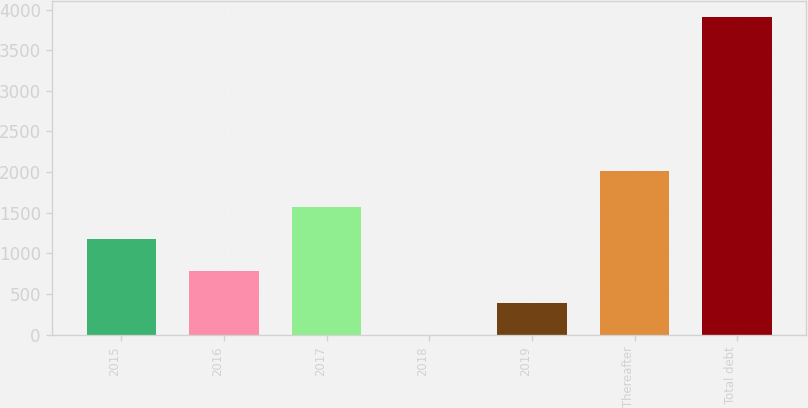Convert chart to OTSL. <chart><loc_0><loc_0><loc_500><loc_500><bar_chart><fcel>2015<fcel>2016<fcel>2017<fcel>2018<fcel>2019<fcel>Thereafter<fcel>Total debt<nl><fcel>1174<fcel>783<fcel>1565<fcel>1<fcel>392<fcel>2009<fcel>3911<nl></chart> 